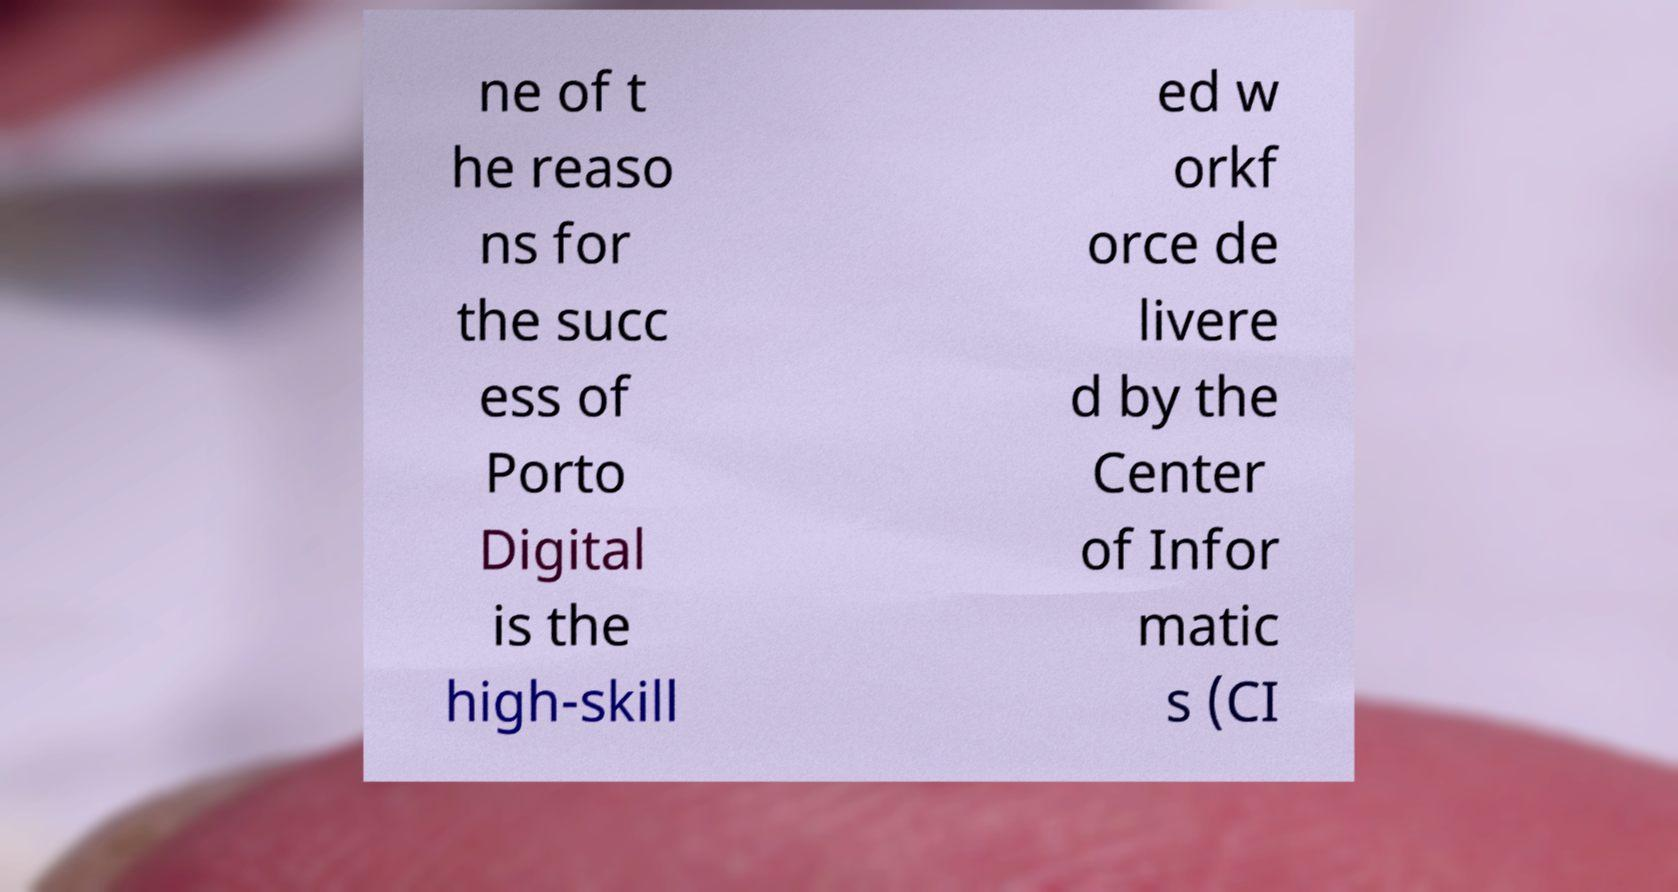Please identify and transcribe the text found in this image. ne of t he reaso ns for the succ ess of Porto Digital is the high-skill ed w orkf orce de livere d by the Center of Infor matic s (CI 